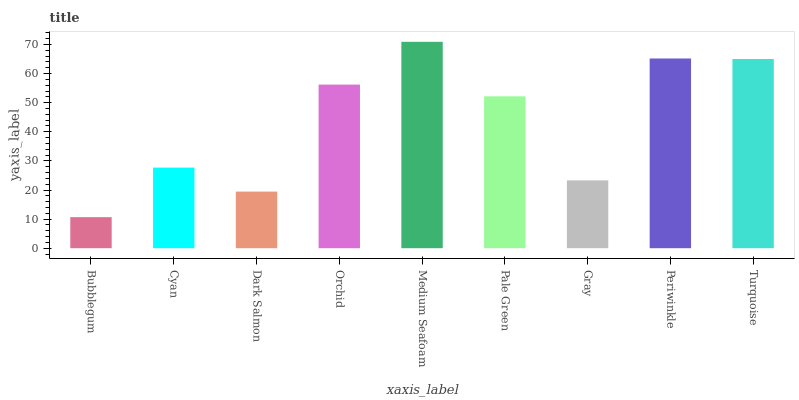Is Bubblegum the minimum?
Answer yes or no. Yes. Is Medium Seafoam the maximum?
Answer yes or no. Yes. Is Cyan the minimum?
Answer yes or no. No. Is Cyan the maximum?
Answer yes or no. No. Is Cyan greater than Bubblegum?
Answer yes or no. Yes. Is Bubblegum less than Cyan?
Answer yes or no. Yes. Is Bubblegum greater than Cyan?
Answer yes or no. No. Is Cyan less than Bubblegum?
Answer yes or no. No. Is Pale Green the high median?
Answer yes or no. Yes. Is Pale Green the low median?
Answer yes or no. Yes. Is Gray the high median?
Answer yes or no. No. Is Periwinkle the low median?
Answer yes or no. No. 